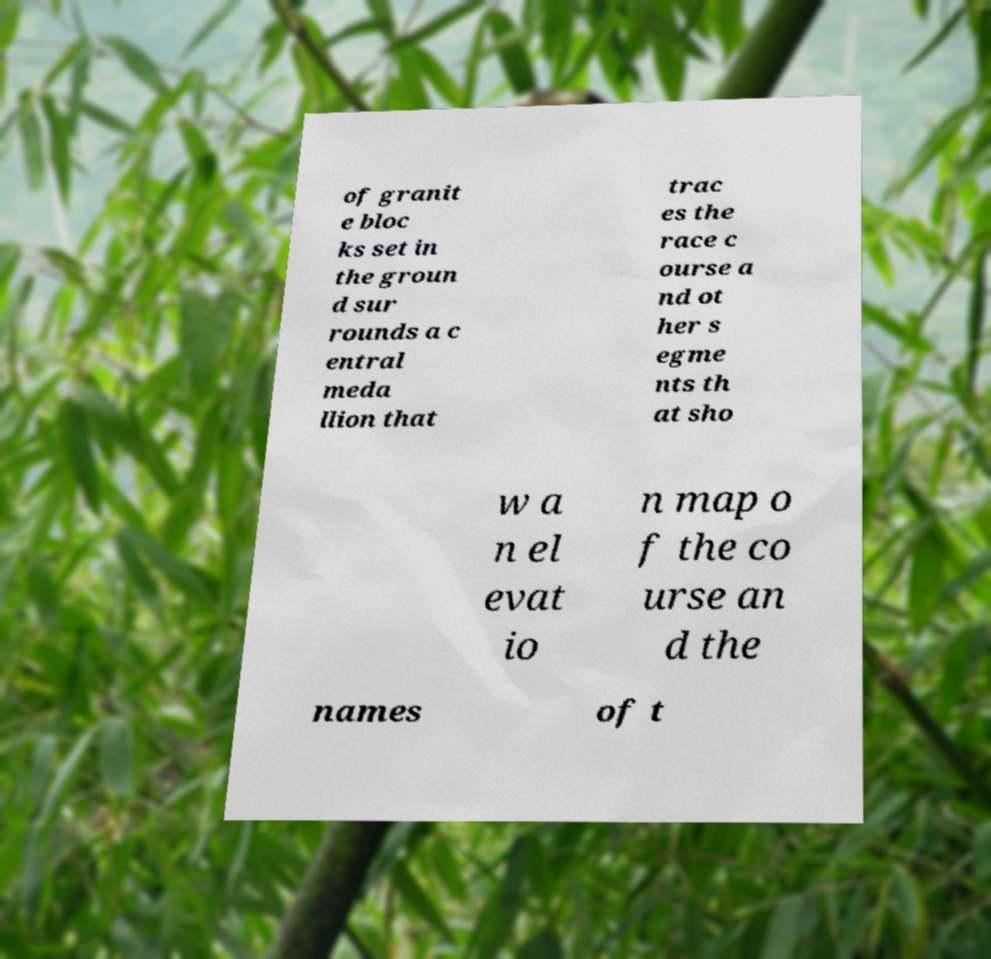What messages or text are displayed in this image? I need them in a readable, typed format. of granit e bloc ks set in the groun d sur rounds a c entral meda llion that trac es the race c ourse a nd ot her s egme nts th at sho w a n el evat io n map o f the co urse an d the names of t 